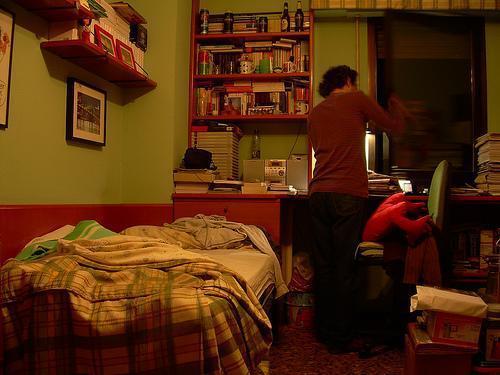How many windows are there?
Give a very brief answer. 1. 